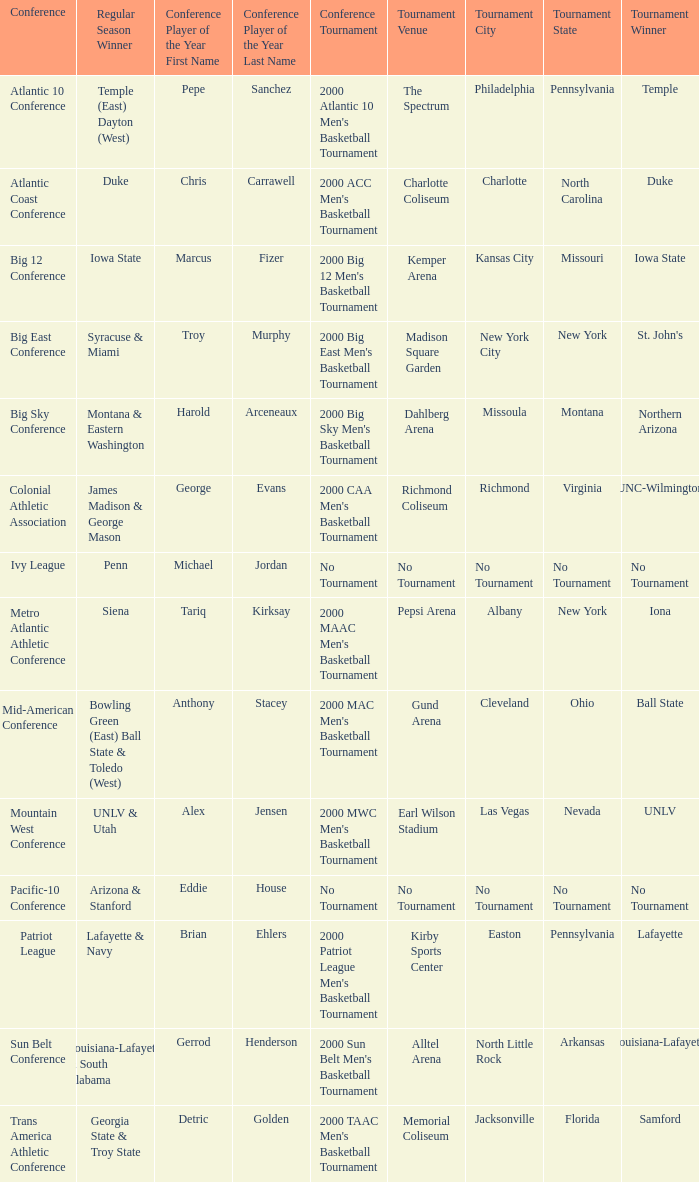What is the number of players of the year in the mountain west conference? 1.0. 